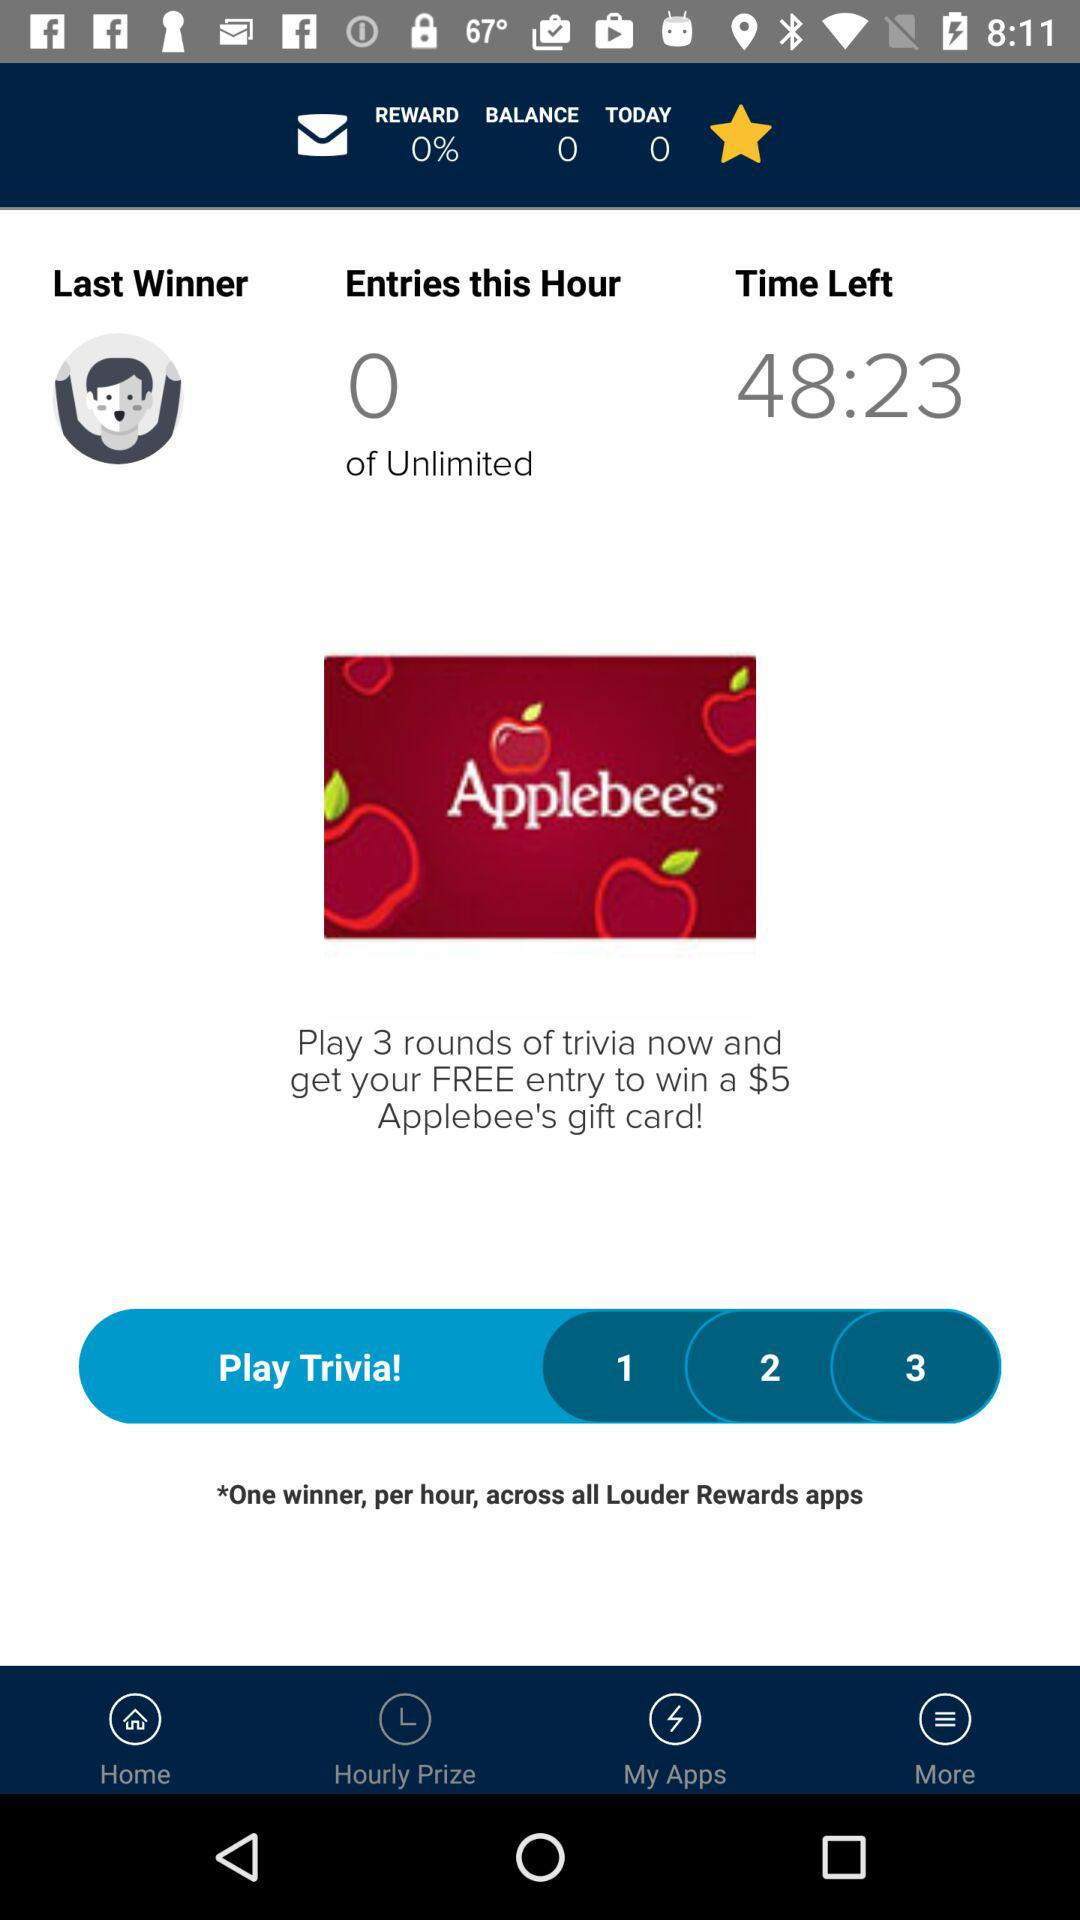How many entries do I need to complete to win the Applebee's gift card?
Answer the question using a single word or phrase. 3 